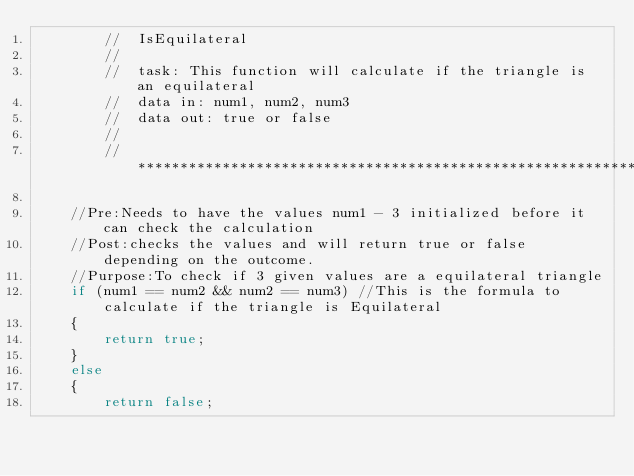<code> <loc_0><loc_0><loc_500><loc_500><_C++_>		//	IsEquilateral
		//
		//	task: This function will calculate if the triangle is an equilateral
		//	data in: num1, num2, num3
		//	data out: true or false
		//
		//********************************************************************

	//Pre:Needs to have the values num1 - 3 initialized before it can check the calculation
	//Post:checks the values and will return true or false depending on the outcome.
	//Purpose:To check if 3 given values are a equilateral triangle
	if (num1 == num2 && num2 == num3) //This is the formula to calculate if the triangle is Equilateral
	{
		return true;
	}
	else
	{
		return false;</code> 